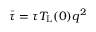<formula> <loc_0><loc_0><loc_500><loc_500>\ B a r { \tau } = \tau T _ { L } ( 0 ) q ^ { 2 }</formula> 